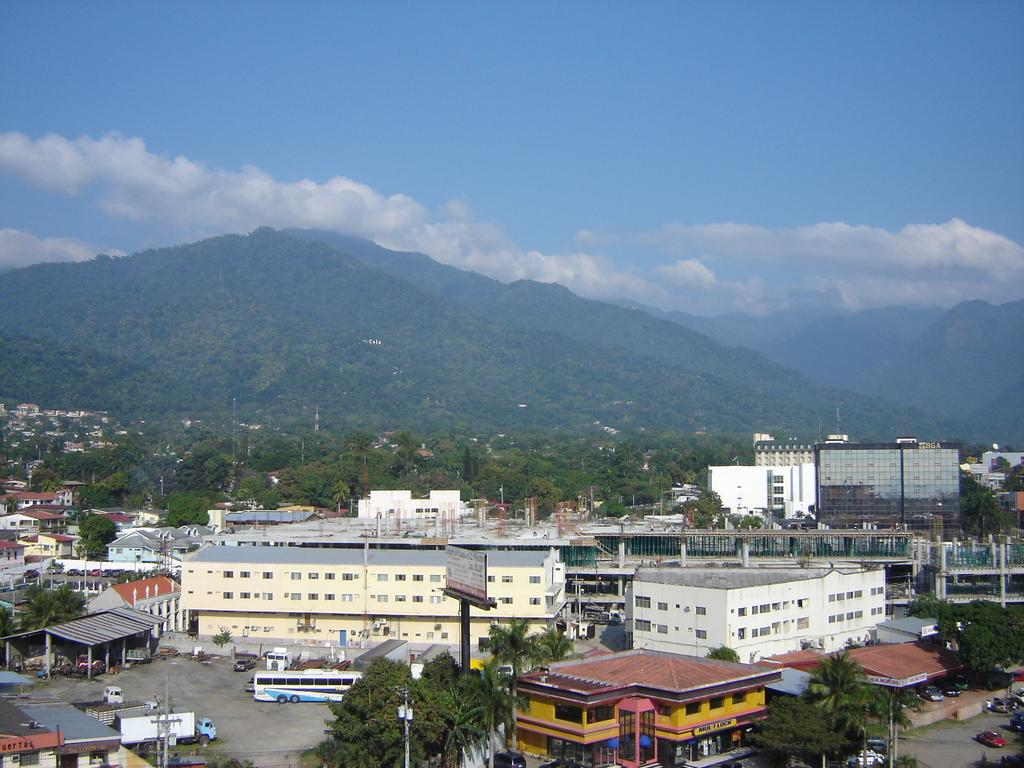What can be seen in the middle of the image? There are trees, buildings, vehicles, sheds, and poles in the middle of the image. What is visible at the top of the image? Hills, sky, and clouds are visible at the top of the image. What type of locket is hanging from the pole in the image? There is no locket present in the image; it features trees, buildings, vehicles, sheds, and poles in the middle, as well as hills, sky, and clouds at the top. What authority is responsible for maintaining order in the image? The image does not depict any authority or order to be maintained; it simply shows a scene with various elements. 